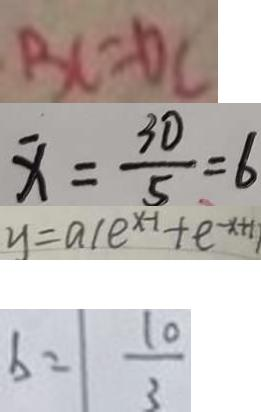<formula> <loc_0><loc_0><loc_500><loc_500>B C = D C 
 x = \frac { 3 0 } { 5 } = 6 
 y = a ( e ^ { x - 1 } + e ^ { - x + 1 } ) 
 b = \frac { 1 0 } { 3 }</formula> 